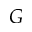<formula> <loc_0><loc_0><loc_500><loc_500>G</formula> 